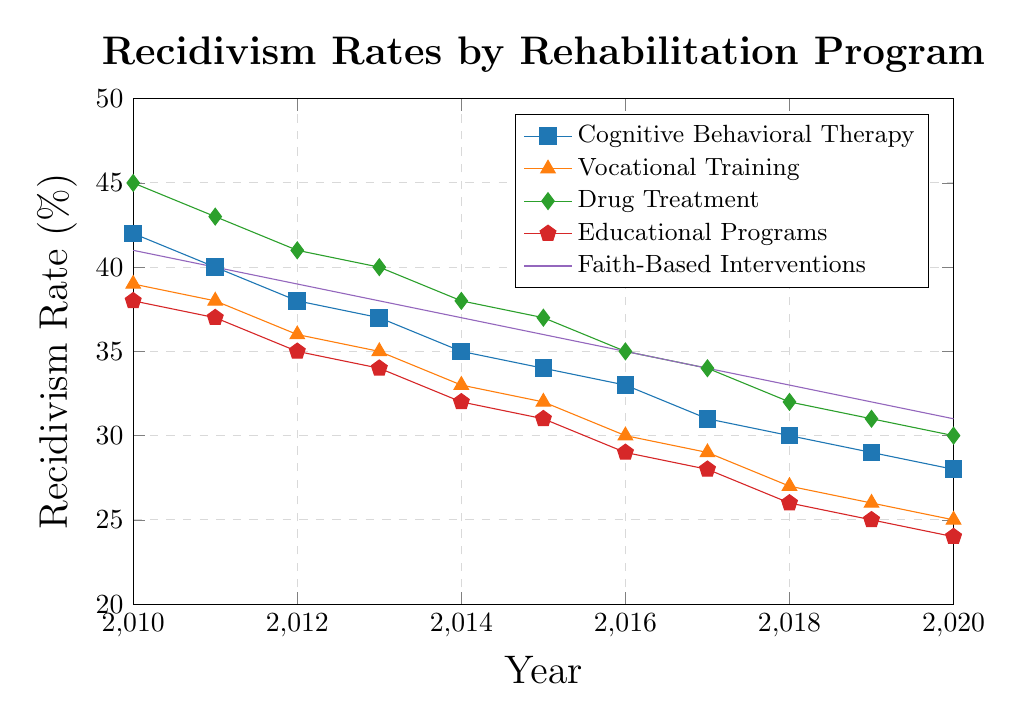Which rehabilitation program has the lowest recidivism rate in 2020? By observing the values at the far right (2020) on the x-axis for each line, the recidivism rates are: Cognitive Behavioral Therapy (28%), Vocational Training (25%), Drug Treatment (30%), Educational Programs (24%), and Faith-Based Interventions (31%). The lowest rate is for Educational Programs.
Answer: Educational Programs Which program showed the greatest reduction in recidivism rate from 2010 to 2020? Calculate the difference between the 2020 and 2010 values for each program: Cognitive Behavioral Therapy (42% to 28% = 14%), Vocational Training (39% to 25% = 14%), Drug Treatment (45% to 30% = 15%), Educational Programs (38% to 24% = 14%), and Faith-Based Interventions (41% to 31% = 10%). Drug Treatment has the greatest reduction of 15%.
Answer: Drug Treatment How did the recidivism rate for Cognitive Behavioral Therapy and Educational Programs compare in 2015? Look at the values in 2015 for both programs: Cognitive Behavioral Therapy (34%) and Educational Programs (31%). Comparing these, Cognitive Behavioral Therapy has a higher recidivism rate than Educational Programs in 2015.
Answer: Cognitive Behavioral Therapy has a higher rate What's the average recidivism rate for Vocational Training over the entire period? Add up all the annual rates for Vocational Training from 2010 to 2020 and divide by the number of years. (39 + 38 + 36 + 35 + 33 + 32 + 30 + 29 + 27 + 26 + 25) / 11 = 35.
Answer: 35 Which program's recidivism rate intersects with Faith-Based Interventions in any year? Evaluating each year, we see that in 2018, Faith-Based Interventions (33%) intersects with Educational Programs (33%).
Answer: Educational Programs Did the recidivism rate for Drug Treatment ever fall below 30%? Examining the trend line for Drug Treatment, it reaches a lowest value of 30% in 2020. Therefore, it never falls below 30%.
Answer: No Which rehabilitation program's recidivism rate reached 26% first? Observing the values, Educational Programs reached 26% by 2018, whereas Vocational Training reached 26% in 2019. Educational Programs was the first.
Answer: Educational Programs Between 2012 and 2016, which program showed the greatest constant decrease each year? Calculate each year's reduction and check the consistency: Cognitive Behavioral Therapy decreases by 1% annually, Vocational Training by slightly over 1%, Drug Treatment by approximately 1%, Educational Programs by approximately 1% annually, and Faith-Based Interventions varies slightly but around 1%. Vocational Training shows the greatest and most consistent reduction annually.
Answer: Vocational Training 